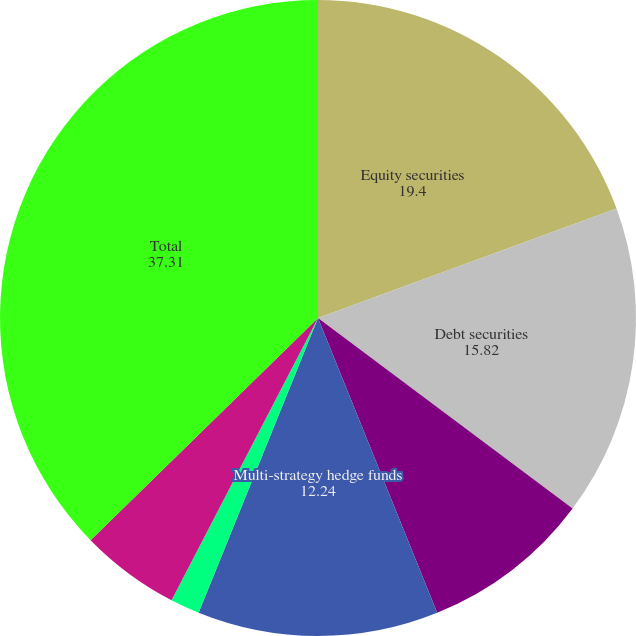Convert chart to OTSL. <chart><loc_0><loc_0><loc_500><loc_500><pie_chart><fcel>Equity securities<fcel>Debt securities<fcel>Real estate funds<fcel>Multi-strategy hedge funds<fcel>Private equity<fcel>Other<fcel>Total<nl><fcel>19.4%<fcel>15.82%<fcel>8.66%<fcel>12.24%<fcel>1.49%<fcel>5.07%<fcel>37.31%<nl></chart> 